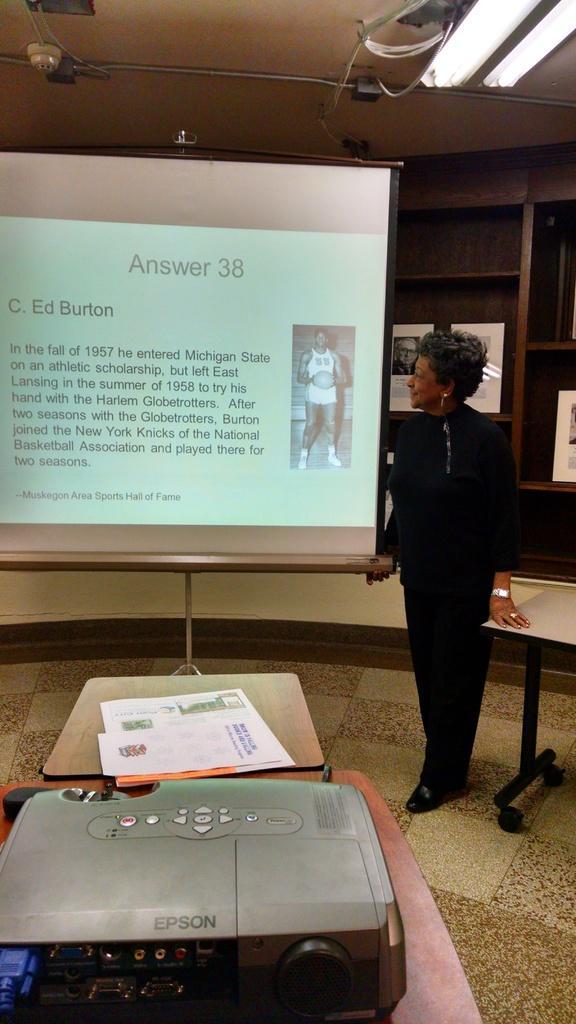Can you describe this image briefly? In this image we can see a woman standing and looking at the projector display, electric lights, projector and some papers on the table. 